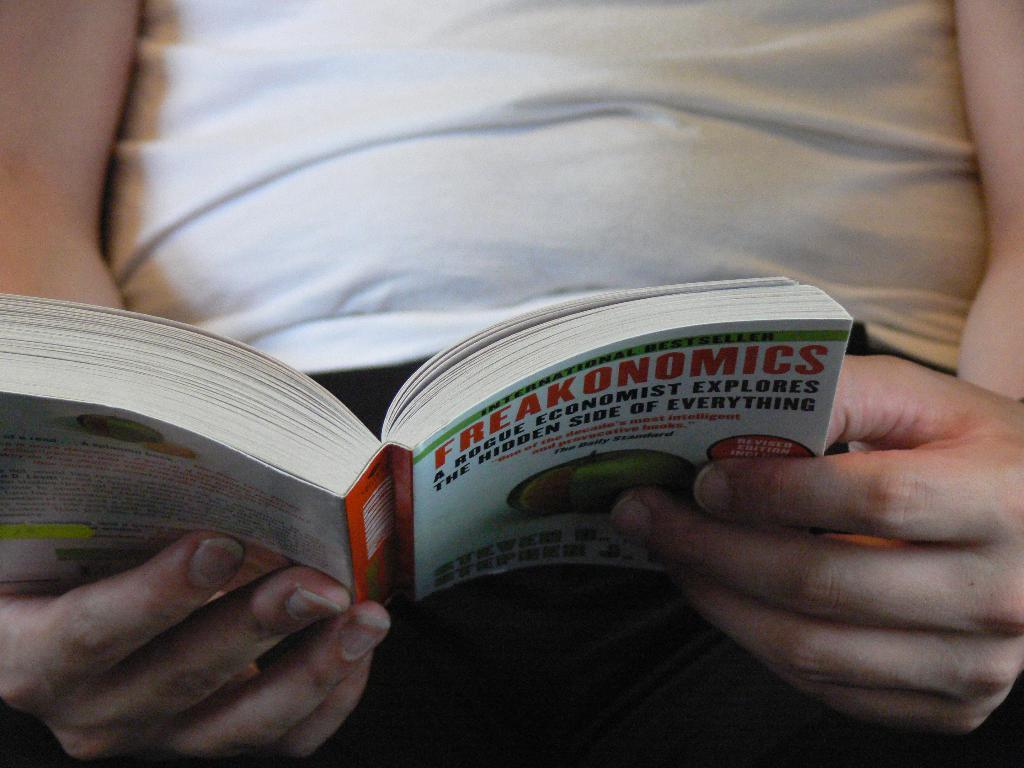<image>
Present a compact description of the photo's key features. A man holding an open book titled Freakonomics. 